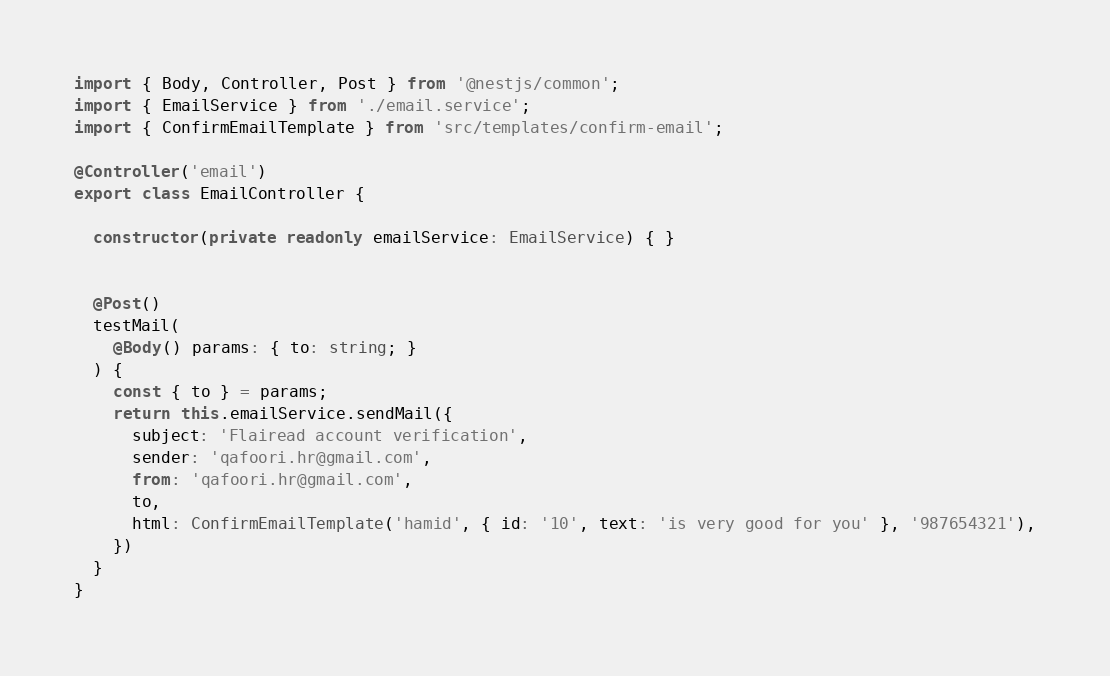<code> <loc_0><loc_0><loc_500><loc_500><_TypeScript_>import { Body, Controller, Post } from '@nestjs/common';
import { EmailService } from './email.service';
import { ConfirmEmailTemplate } from 'src/templates/confirm-email';

@Controller('email')
export class EmailController {

  constructor(private readonly emailService: EmailService) { }


  @Post()
  testMail(
    @Body() params: { to: string; }
  ) {
    const { to } = params;
    return this.emailService.sendMail({
      subject: 'Flairead account verification',
      sender: 'qafoori.hr@gmail.com',
      from: 'qafoori.hr@gmail.com',
      to,
      html: ConfirmEmailTemplate('hamid', { id: '10', text: 'is very good for you' }, '987654321'),
    })
  }
}
</code> 